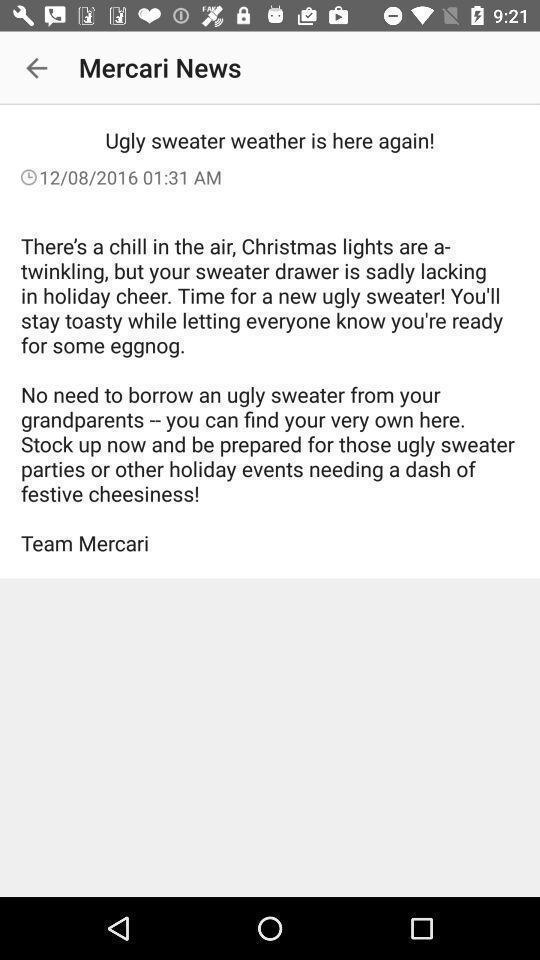Provide a description of this screenshot. Page showing about news article. 